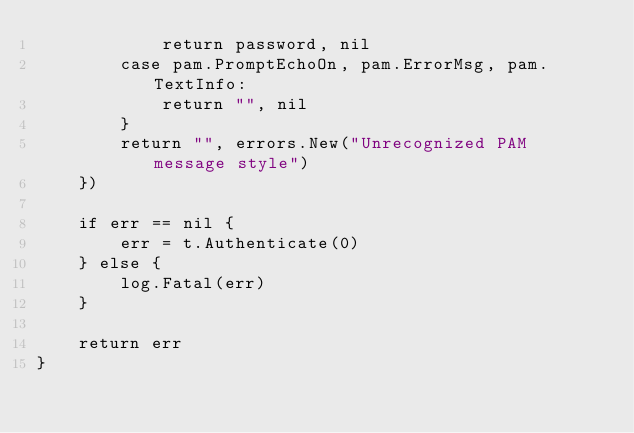<code> <loc_0><loc_0><loc_500><loc_500><_Go_>			return password, nil
		case pam.PromptEchoOn, pam.ErrorMsg, pam.TextInfo:
			return "", nil
		}
		return "", errors.New("Unrecognized PAM message style")
	})

	if err == nil {
		err = t.Authenticate(0)
	} else {
		log.Fatal(err)
	}

	return err
}
</code> 